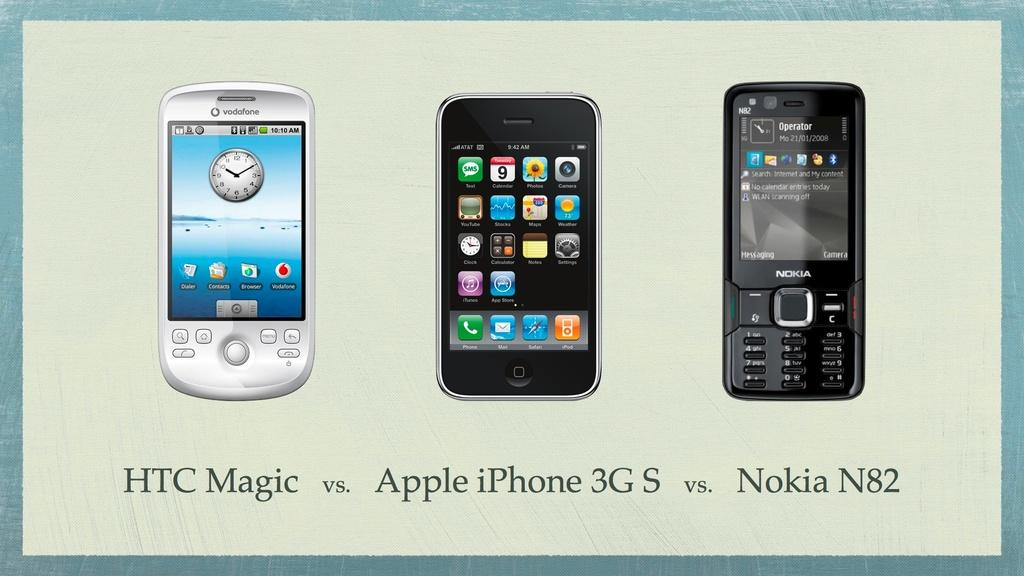<image>
Write a terse but informative summary of the picture. An HTC Magic phone and a Apple I phone and a Nokia handset are arranged in a which one is best formation. 